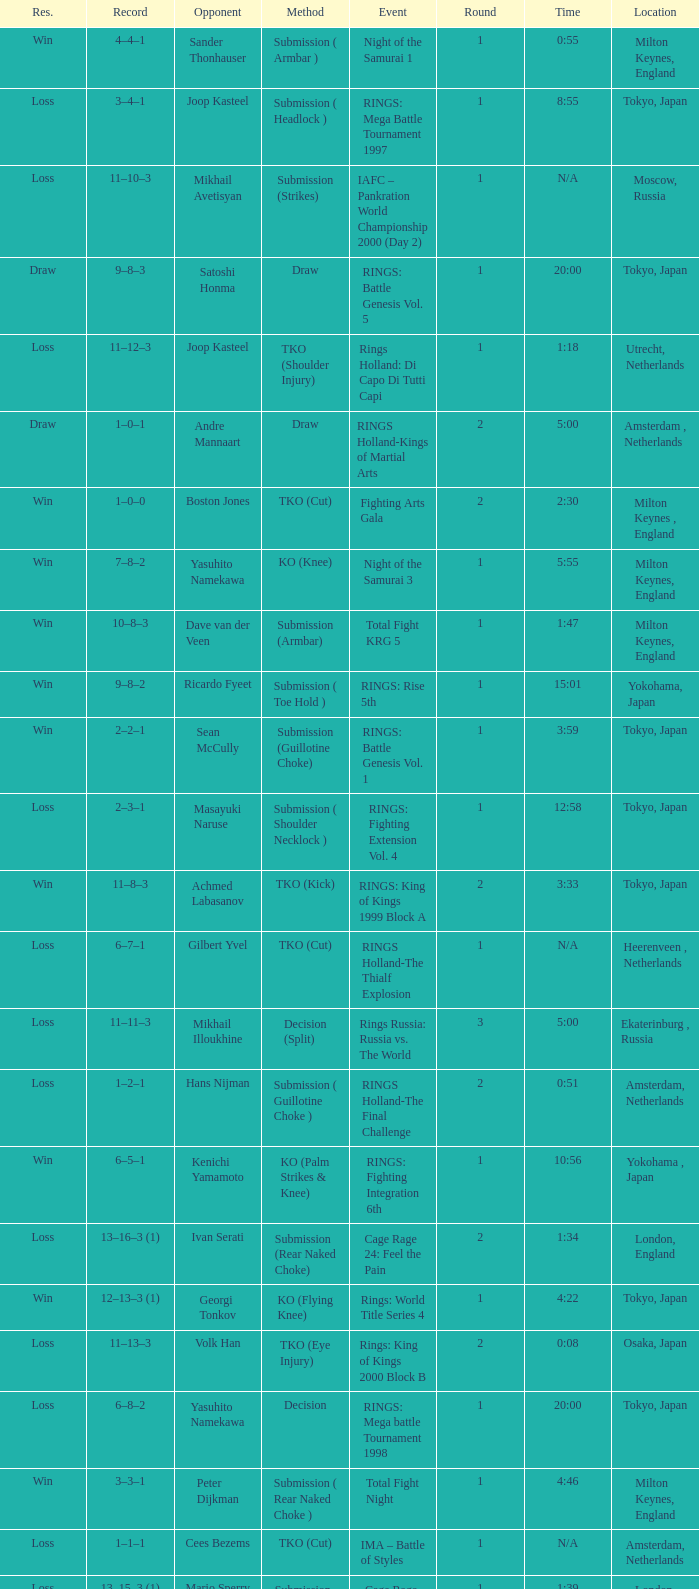Who was the opponent in London, England in a round less than 2? Mario Sperry. 